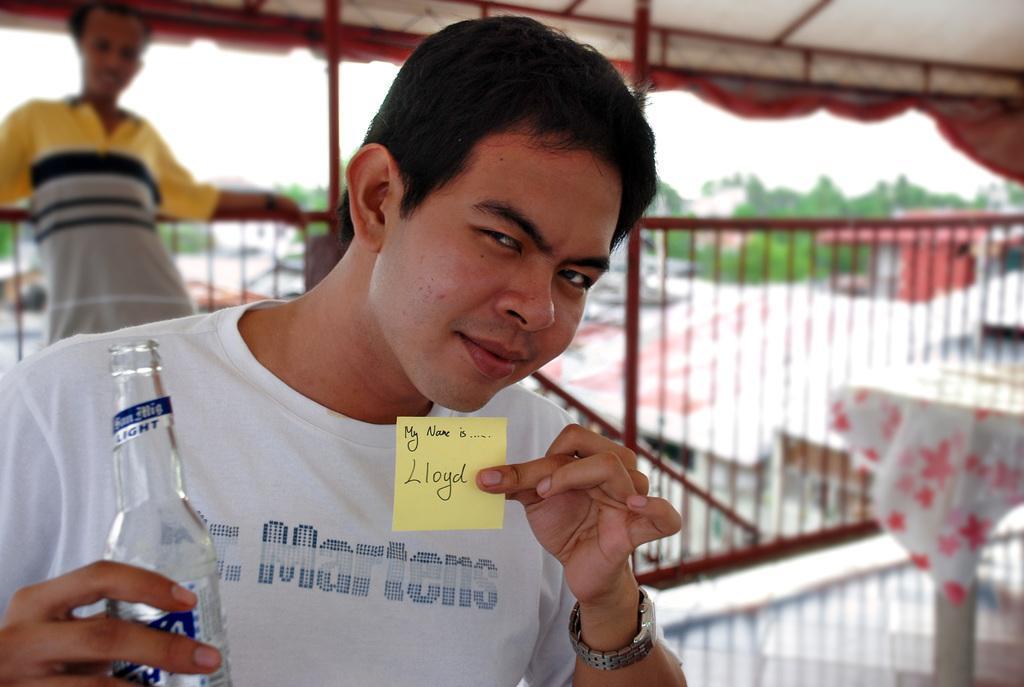Describe this image in one or two sentences. This person is holding a note and bottle. Far this person is standing. We can able to see number of trees. 